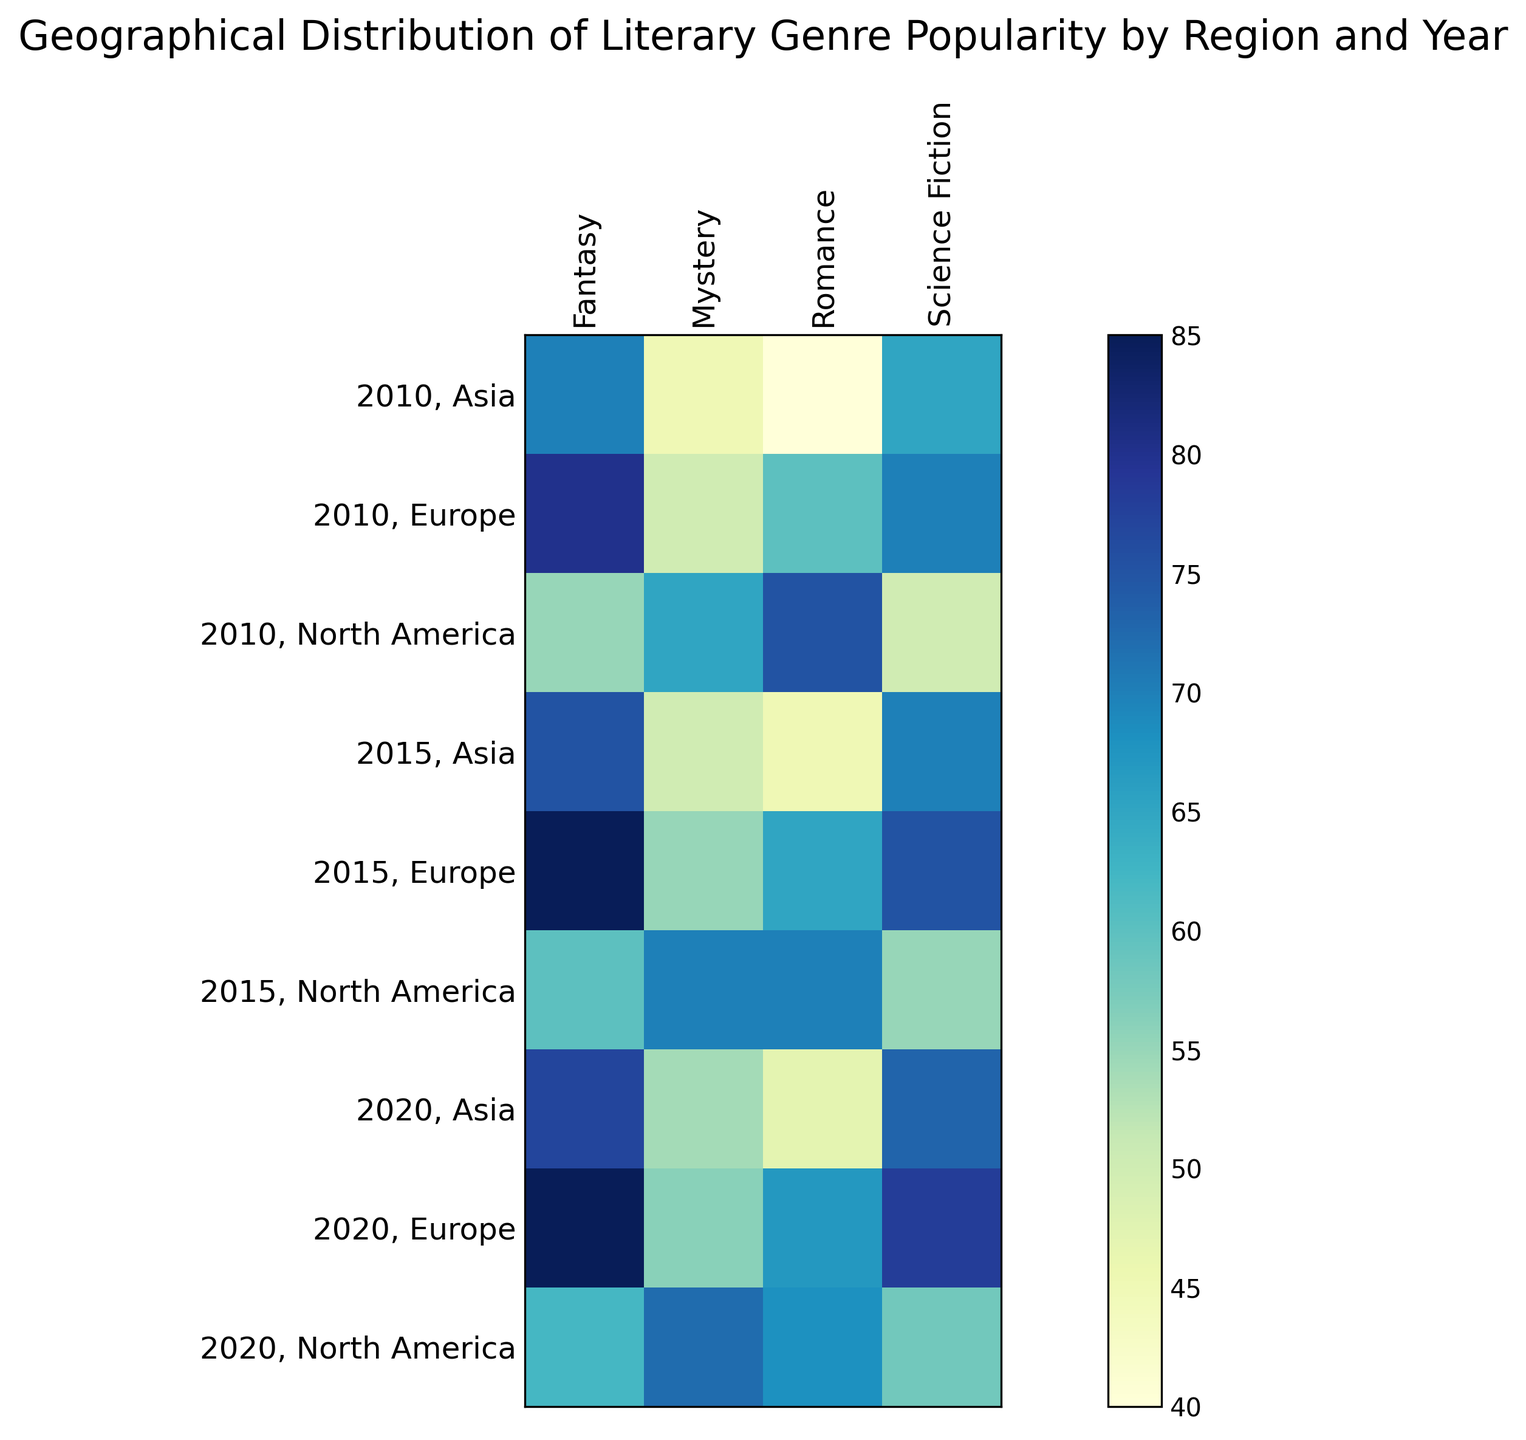Which region had the highest popularity score for Fantasy in 2020? Look at the cells for Fantasy in 2020 across different regions. The highest value is in Europe.
Answer: Europe What was the difference in popularity score for Romance between 2010 and 2020 in North America? Subtract the value for Romance in 2020 from the value in 2010 for North America: 75 (2010) - 68 (2020).
Answer: 7 Which year showed the highest increase in popularity for Science Fiction in Europe? Compare the scores for Science Fiction in Europe across the years. The increase from 2010 to 2015 is 70 to 75, and from 2015 to 2020 is 75 to 78, so the highest increase is from 2010 to 2015.
Answer: 2010 to 2015 Rank the genres based on their overall popularity in Asia in 2020. Look at the scores for all genres in Asia in 2020 and rank them: Fantasy (77), Science Fiction (73), Mystery (54), Romance (47).
Answer: Fantasy, Science Fiction, Mystery, Romance Which genre showed the most consistent popularity trends in North America over the years? Compare the values for each genre in North America across the years. Science Fiction has the most consistent trend: 50 (2010), 55 (2015), 58 (2020).
Answer: Science Fiction How much did the popularity of Mystery in Asia increase from 2010 to 2020? Subtract the value for Mystery in 2010 from the value in 2020 for Asia: 54 (2020) - 45 (2010).
Answer: 9 Which region had the lowest popularity score for Romance in 2010? Look at the Romance scores in 2010 across all regions. The lowest value is in Asia.
Answer: Asia What is the average popularity score for Fantasy across all regions in 2015? Add the Fantasy scores for 2015 and divide by the number of regions: (60 + 85 + 75) / 3 = 220 / 3.
Answer: 73.33 In which year did Europe see the highest popularity for Mystery? Compare the Mystery scores for Europe across all years. The highest value is in 2020.
Answer: 2020 Which genre in Europe had the highest growth between 2010 and 2015? Calculate the differences in scores for each genre from 2010 to 2015 in Europe: Romance (65-60=5), Science Fiction (75-70=5), Mystery (55-50=5), Fantasy (85-80=5). All genres grew evenly.
Answer: All genres 